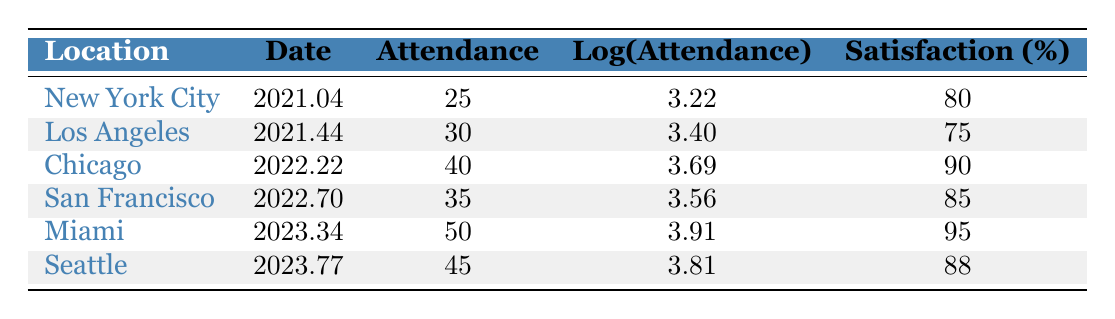What is the date of the workshop held in Chicago? The table shows that the Chicago workshop took place on March 22, 2022.
Answer: March 22, 2022 What was the participant satisfaction percentage for the Los Angeles workshop? Looking at the row for Los Angeles, the participant satisfaction percentage is noted as 75%.
Answer: 75% Which location had the lowest attendance, and what was that attendance? By scanning the attendance figures, we see New York City had the lowest attendance with 25 participants.
Answer: New York City, 25 What is the average participant satisfaction across all workshops listed? To find the average, we sum the satisfaction percentages (80 + 75 + 90 + 85 + 95 + 88 = 513) and divide by the number of workshops (6). So, 513/6 = 85.5.
Answer: 85.5 Did the attendance in Seattle exceed that of the workshop held in Los Angeles? Seattle had an attendance of 45, while Los Angeles had 30, so Seattle's attendance does exceed that of Los Angeles.
Answer: Yes Is it true that participant satisfaction in Miami was higher than in San Francisco? Miami had a satisfaction rate of 95 and San Francisco had 85, indicating Miami's satisfaction was indeed higher.
Answer: Yes What was the difference in attendance between the workshop in Seattle and the one in Miami? Seattle had an attendance of 45, and Miami had 50. The difference is calculated as 50 - 45, which equals 5.
Answer: 5 Which workshop had the highest attendance, and what is its log value? Miami had the highest attendance with 50 participants, and the log value of attendance for Miami is noted as 3.91.
Answer: Miami, 3.91 Identify the location with the highest participant satisfaction and state that percentage. The highest participant satisfaction percentage is 95%, which was achieved at the Miami workshop.
Answer: Miami, 95 